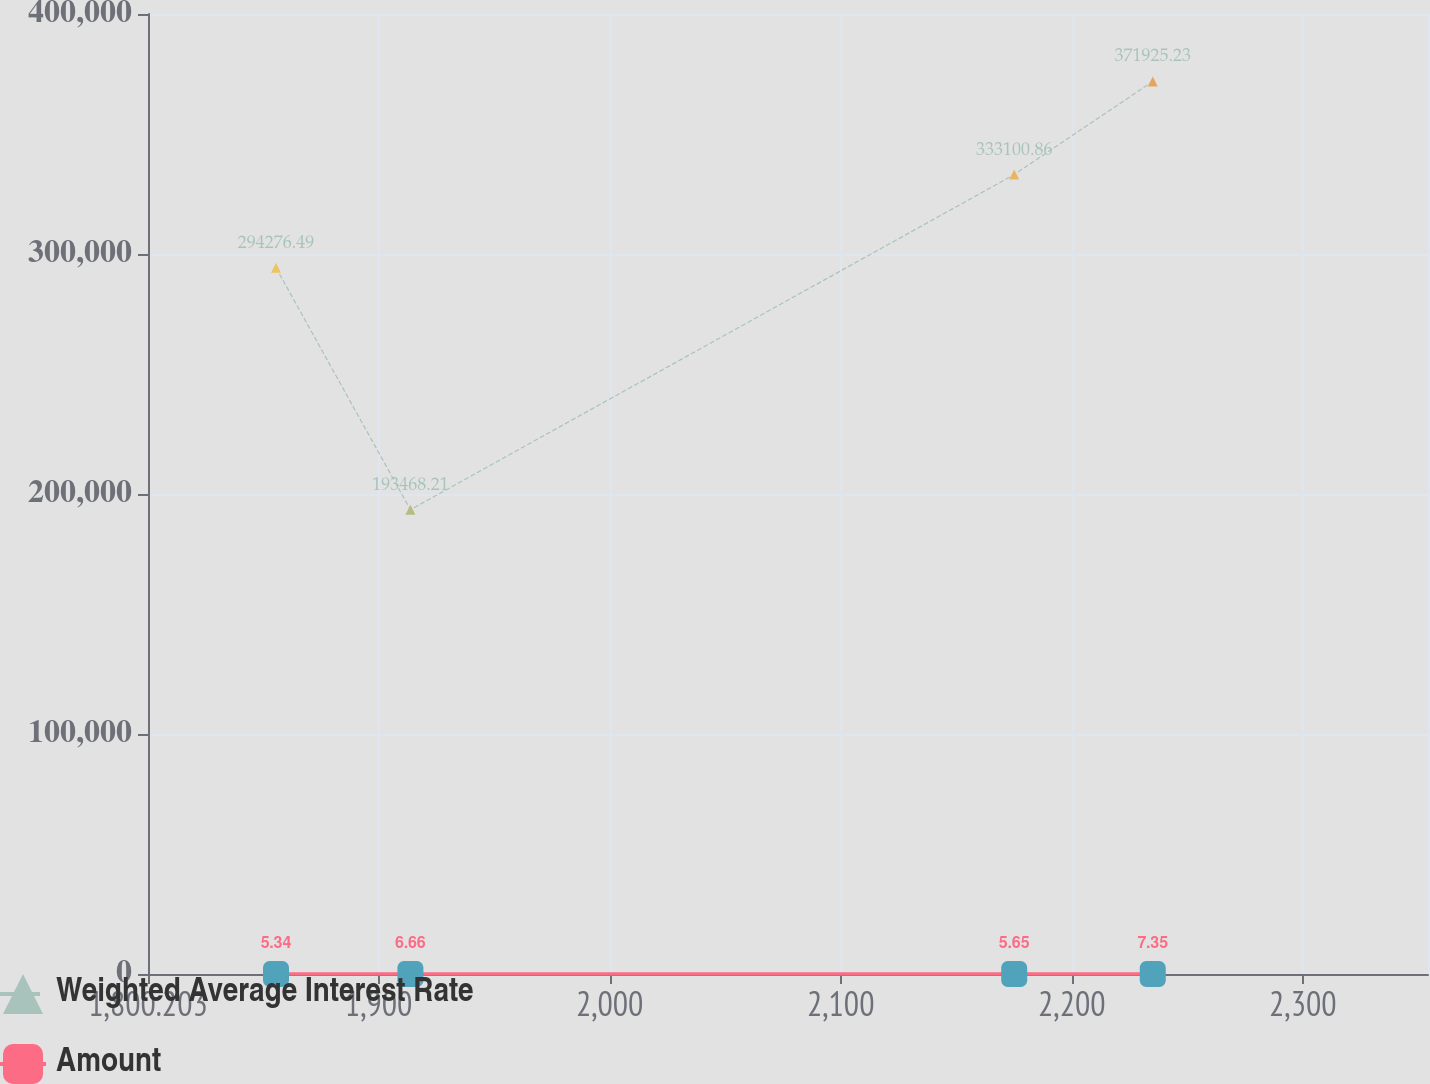<chart> <loc_0><loc_0><loc_500><loc_500><line_chart><ecel><fcel>Weighted Average Interest Rate<fcel>Amount<nl><fcel>1855.6<fcel>294276<fcel>5.34<nl><fcel>1913.77<fcel>193468<fcel>6.66<nl><fcel>2175.09<fcel>333101<fcel>5.65<nl><fcel>2235.05<fcel>371925<fcel>7.35<nl><fcel>2409.57<fcel>581712<fcel>5.88<nl></chart> 